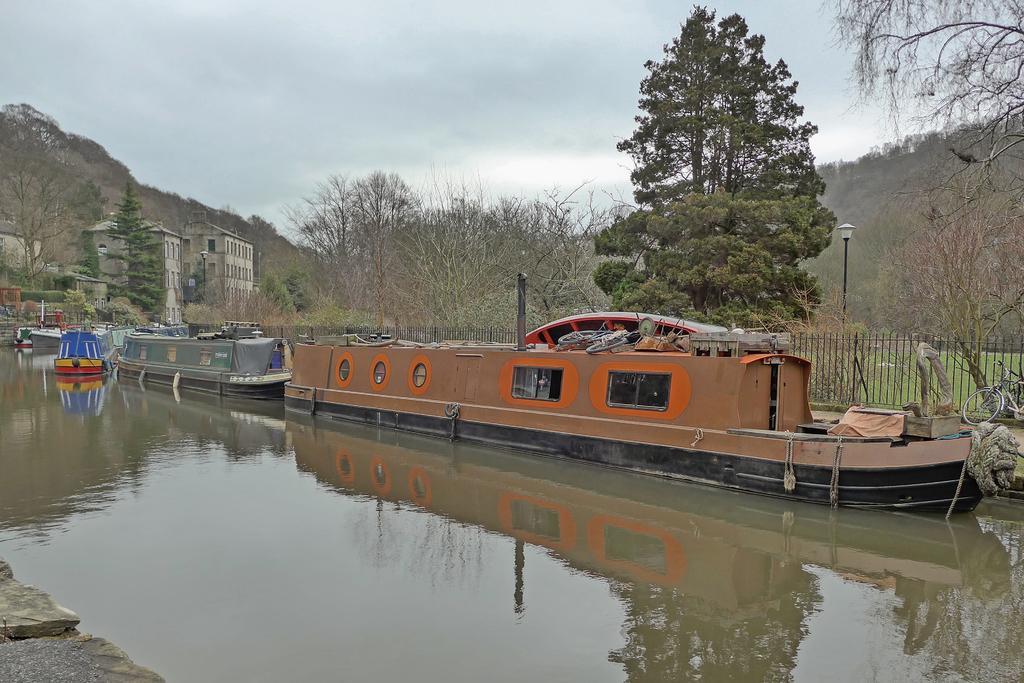How would you summarize this image in a sentence or two? At the bottom of the image there is water. On the water there are ships. On the right corner of the image there is a bicycle. Behind the ships there is fencing. Behind the fencing there are trees and also there are few buildings. At the top of the image there is sky. 